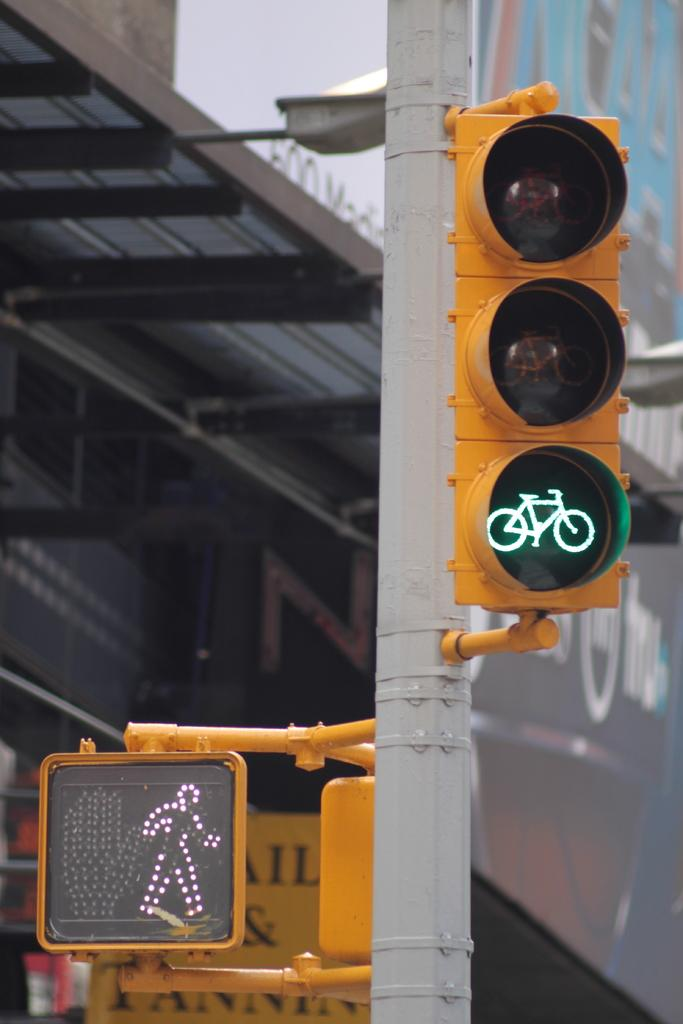<image>
Write a terse but informative summary of the picture. a sing with a walk symbol and also a bike one 